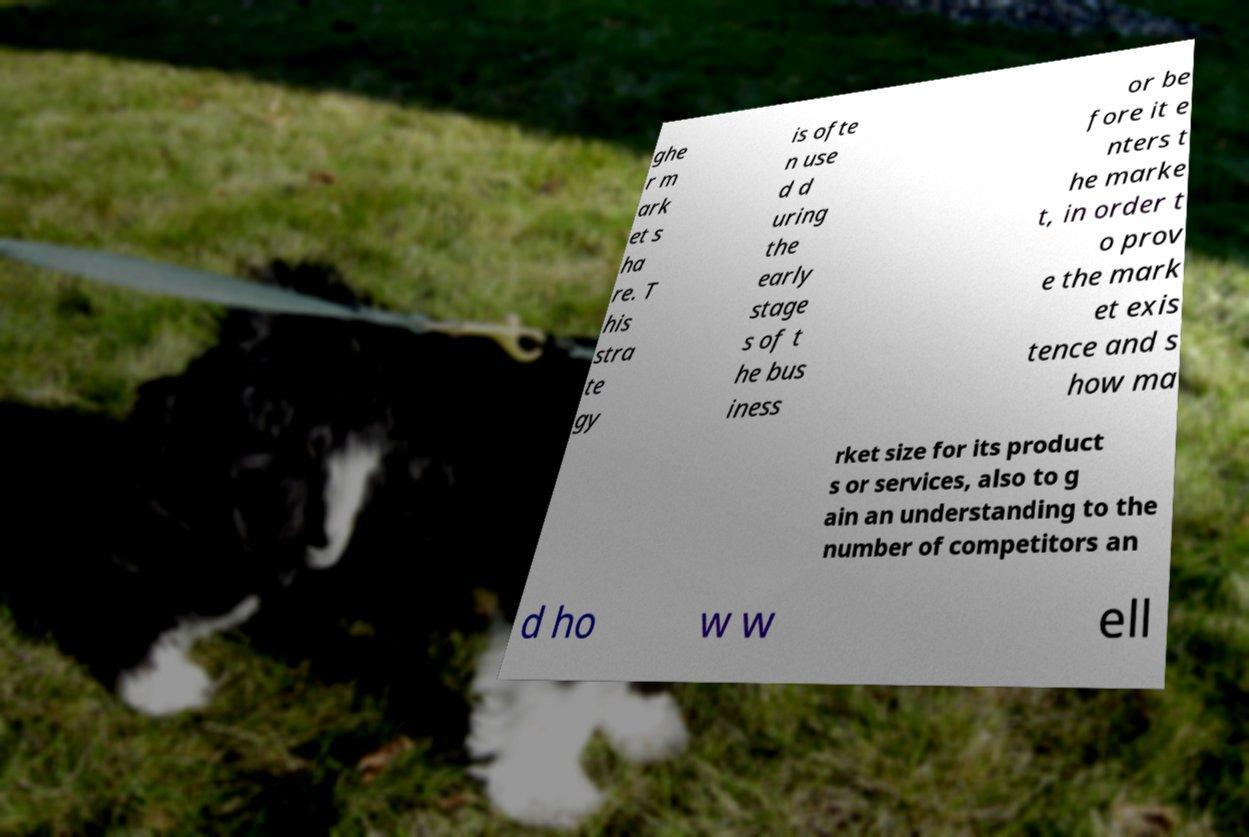Can you accurately transcribe the text from the provided image for me? ghe r m ark et s ha re. T his stra te gy is ofte n use d d uring the early stage s of t he bus iness or be fore it e nters t he marke t, in order t o prov e the mark et exis tence and s how ma rket size for its product s or services, also to g ain an understanding to the number of competitors an d ho w w ell 